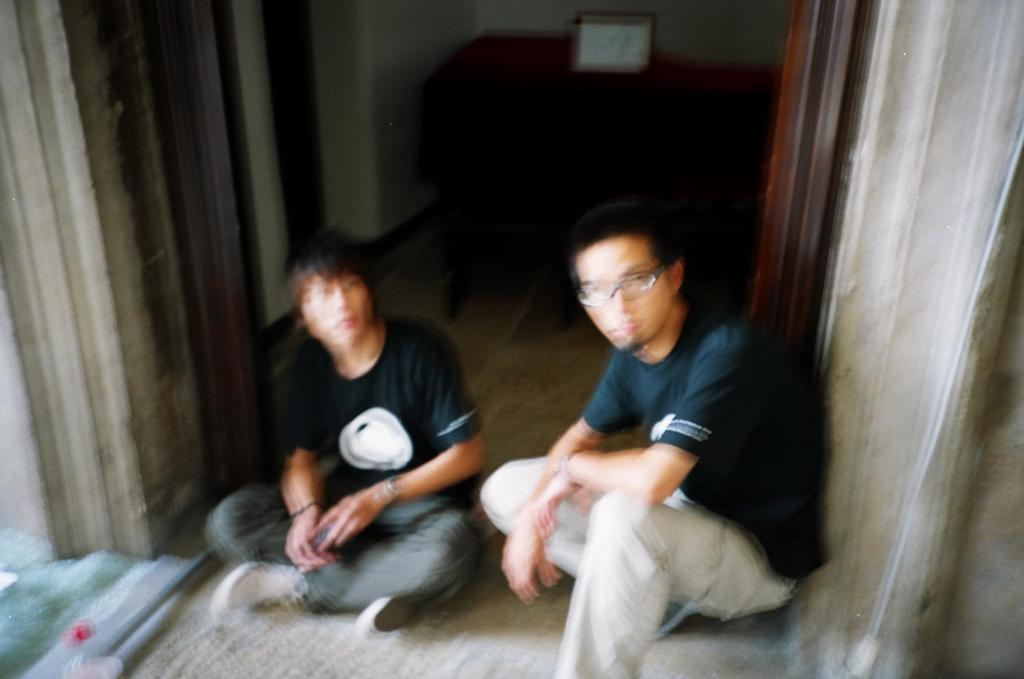How many people are in the image? There are two persons in the image. What can be seen under the people's feet in the image? The floor is visible in the image. What surrounds the people and the floor in the image? The walls are visible in the image. What else can be seen in the image besides the people and the floor? There are objects in the image. What word is being used to whip the rain in the image? There is no mention of a word, whip, or rain in the image. 